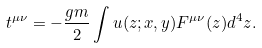Convert formula to latex. <formula><loc_0><loc_0><loc_500><loc_500>t ^ { \mu \nu } = - \frac { g m } { 2 } \int u ( z ; x , y ) F ^ { \mu \nu } ( z ) d ^ { 4 } z .</formula> 